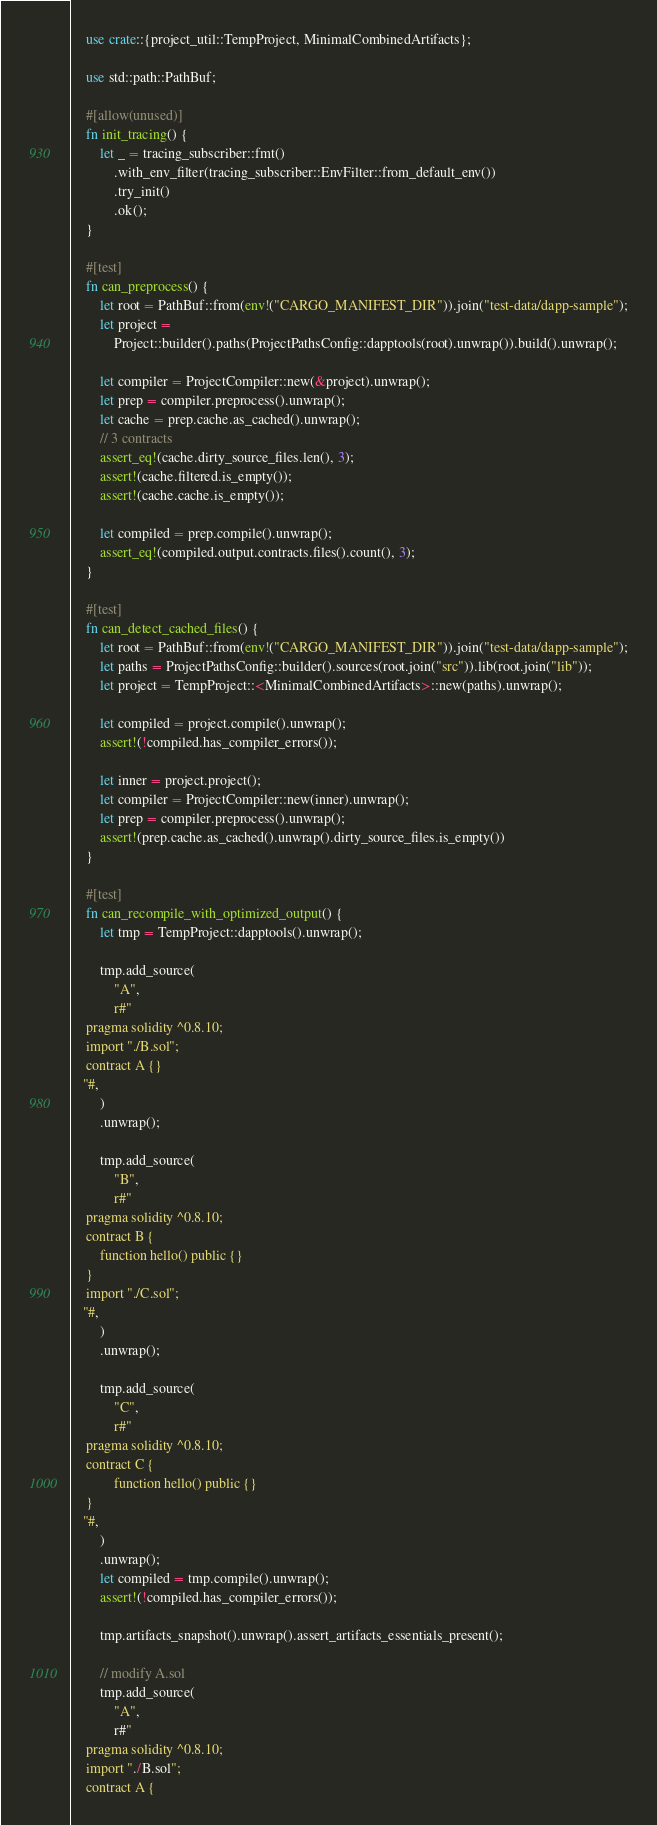<code> <loc_0><loc_0><loc_500><loc_500><_Rust_>    use crate::{project_util::TempProject, MinimalCombinedArtifacts};

    use std::path::PathBuf;

    #[allow(unused)]
    fn init_tracing() {
        let _ = tracing_subscriber::fmt()
            .with_env_filter(tracing_subscriber::EnvFilter::from_default_env())
            .try_init()
            .ok();
    }

    #[test]
    fn can_preprocess() {
        let root = PathBuf::from(env!("CARGO_MANIFEST_DIR")).join("test-data/dapp-sample");
        let project =
            Project::builder().paths(ProjectPathsConfig::dapptools(root).unwrap()).build().unwrap();

        let compiler = ProjectCompiler::new(&project).unwrap();
        let prep = compiler.preprocess().unwrap();
        let cache = prep.cache.as_cached().unwrap();
        // 3 contracts
        assert_eq!(cache.dirty_source_files.len(), 3);
        assert!(cache.filtered.is_empty());
        assert!(cache.cache.is_empty());

        let compiled = prep.compile().unwrap();
        assert_eq!(compiled.output.contracts.files().count(), 3);
    }

    #[test]
    fn can_detect_cached_files() {
        let root = PathBuf::from(env!("CARGO_MANIFEST_DIR")).join("test-data/dapp-sample");
        let paths = ProjectPathsConfig::builder().sources(root.join("src")).lib(root.join("lib"));
        let project = TempProject::<MinimalCombinedArtifacts>::new(paths).unwrap();

        let compiled = project.compile().unwrap();
        assert!(!compiled.has_compiler_errors());

        let inner = project.project();
        let compiler = ProjectCompiler::new(inner).unwrap();
        let prep = compiler.preprocess().unwrap();
        assert!(prep.cache.as_cached().unwrap().dirty_source_files.is_empty())
    }

    #[test]
    fn can_recompile_with_optimized_output() {
        let tmp = TempProject::dapptools().unwrap();

        tmp.add_source(
            "A",
            r#"
    pragma solidity ^0.8.10;
    import "./B.sol";
    contract A {}
   "#,
        )
        .unwrap();

        tmp.add_source(
            "B",
            r#"
    pragma solidity ^0.8.10;
    contract B {
        function hello() public {}
    }
    import "./C.sol";
   "#,
        )
        .unwrap();

        tmp.add_source(
            "C",
            r#"
    pragma solidity ^0.8.10;
    contract C {
            function hello() public {}
    }
   "#,
        )
        .unwrap();
        let compiled = tmp.compile().unwrap();
        assert!(!compiled.has_compiler_errors());

        tmp.artifacts_snapshot().unwrap().assert_artifacts_essentials_present();

        // modify A.sol
        tmp.add_source(
            "A",
            r#"
    pragma solidity ^0.8.10;
    import "./B.sol";
    contract A {</code> 